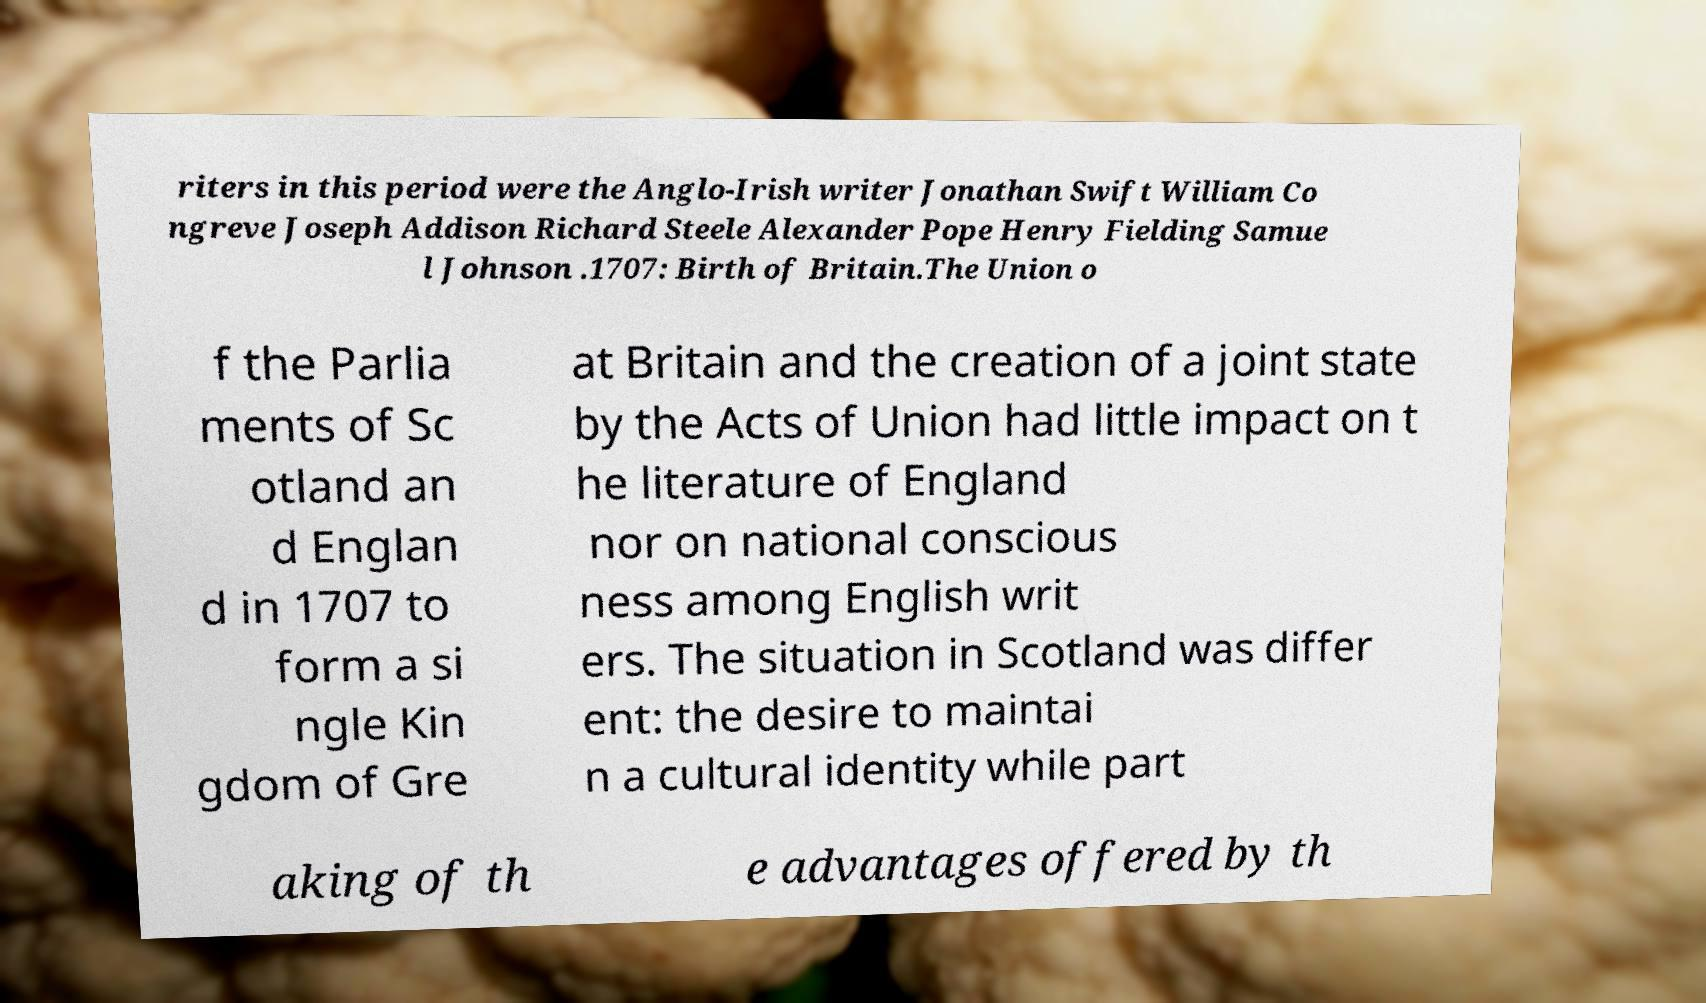Could you extract and type out the text from this image? riters in this period were the Anglo-Irish writer Jonathan Swift William Co ngreve Joseph Addison Richard Steele Alexander Pope Henry Fielding Samue l Johnson .1707: Birth of Britain.The Union o f the Parlia ments of Sc otland an d Englan d in 1707 to form a si ngle Kin gdom of Gre at Britain and the creation of a joint state by the Acts of Union had little impact on t he literature of England nor on national conscious ness among English writ ers. The situation in Scotland was differ ent: the desire to maintai n a cultural identity while part aking of th e advantages offered by th 